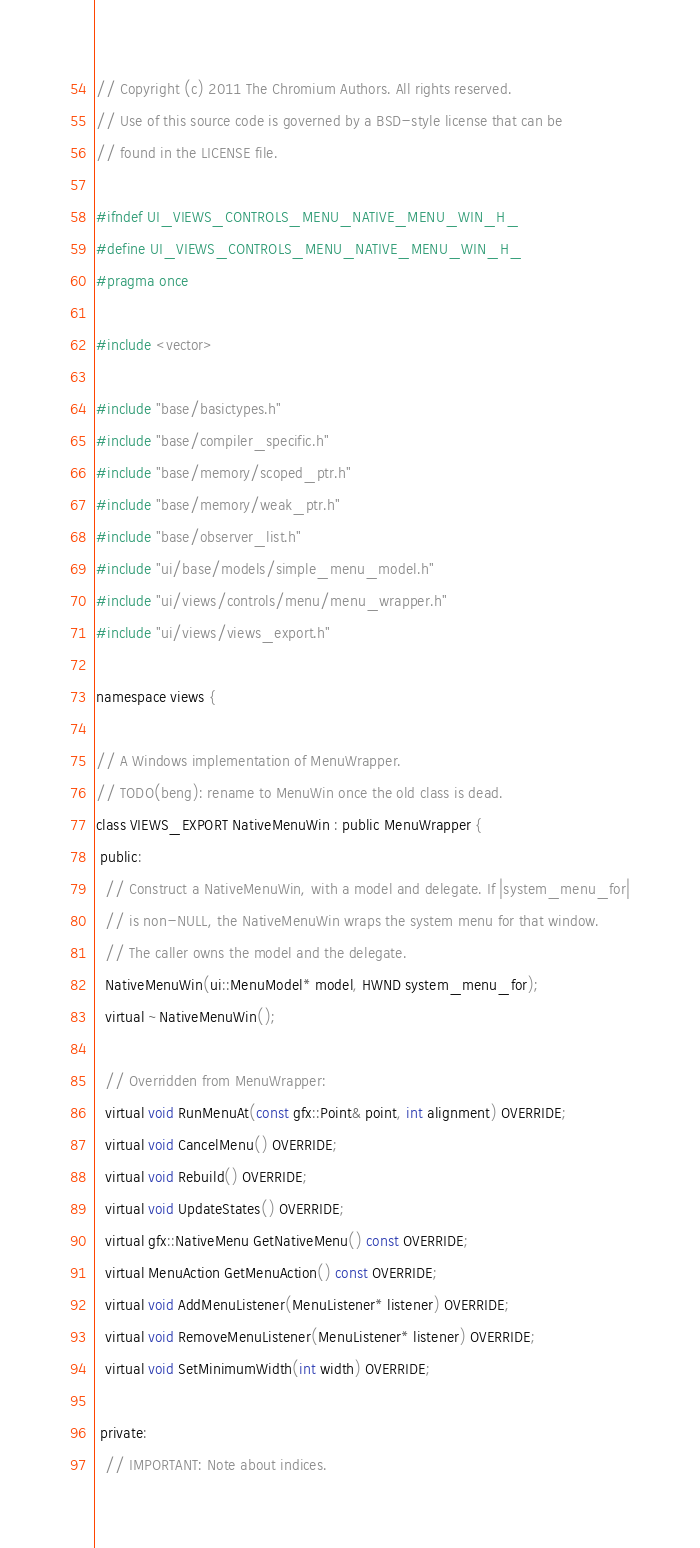<code> <loc_0><loc_0><loc_500><loc_500><_C_>// Copyright (c) 2011 The Chromium Authors. All rights reserved.
// Use of this source code is governed by a BSD-style license that can be
// found in the LICENSE file.

#ifndef UI_VIEWS_CONTROLS_MENU_NATIVE_MENU_WIN_H_
#define UI_VIEWS_CONTROLS_MENU_NATIVE_MENU_WIN_H_
#pragma once

#include <vector>

#include "base/basictypes.h"
#include "base/compiler_specific.h"
#include "base/memory/scoped_ptr.h"
#include "base/memory/weak_ptr.h"
#include "base/observer_list.h"
#include "ui/base/models/simple_menu_model.h"
#include "ui/views/controls/menu/menu_wrapper.h"
#include "ui/views/views_export.h"

namespace views {

// A Windows implementation of MenuWrapper.
// TODO(beng): rename to MenuWin once the old class is dead.
class VIEWS_EXPORT NativeMenuWin : public MenuWrapper {
 public:
  // Construct a NativeMenuWin, with a model and delegate. If |system_menu_for|
  // is non-NULL, the NativeMenuWin wraps the system menu for that window.
  // The caller owns the model and the delegate.
  NativeMenuWin(ui::MenuModel* model, HWND system_menu_for);
  virtual ~NativeMenuWin();

  // Overridden from MenuWrapper:
  virtual void RunMenuAt(const gfx::Point& point, int alignment) OVERRIDE;
  virtual void CancelMenu() OVERRIDE;
  virtual void Rebuild() OVERRIDE;
  virtual void UpdateStates() OVERRIDE;
  virtual gfx::NativeMenu GetNativeMenu() const OVERRIDE;
  virtual MenuAction GetMenuAction() const OVERRIDE;
  virtual void AddMenuListener(MenuListener* listener) OVERRIDE;
  virtual void RemoveMenuListener(MenuListener* listener) OVERRIDE;
  virtual void SetMinimumWidth(int width) OVERRIDE;

 private:
  // IMPORTANT: Note about indices.</code> 